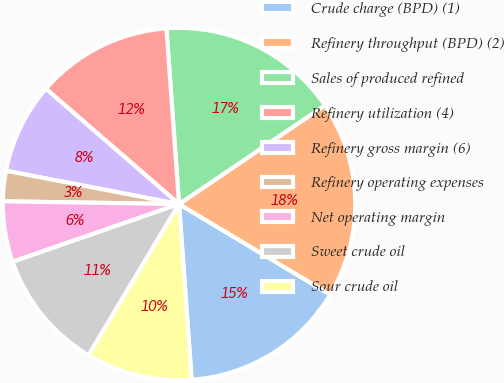Convert chart. <chart><loc_0><loc_0><loc_500><loc_500><pie_chart><fcel>Crude charge (BPD) (1)<fcel>Refinery throughput (BPD) (2)<fcel>Sales of produced refined<fcel>Refinery utilization (4)<fcel>Refinery gross margin (6)<fcel>Refinery operating expenses<fcel>Net operating margin<fcel>Sweet crude oil<fcel>Sour crude oil<nl><fcel>15.28%<fcel>18.06%<fcel>16.67%<fcel>12.5%<fcel>8.33%<fcel>2.78%<fcel>5.56%<fcel>11.11%<fcel>9.72%<nl></chart> 